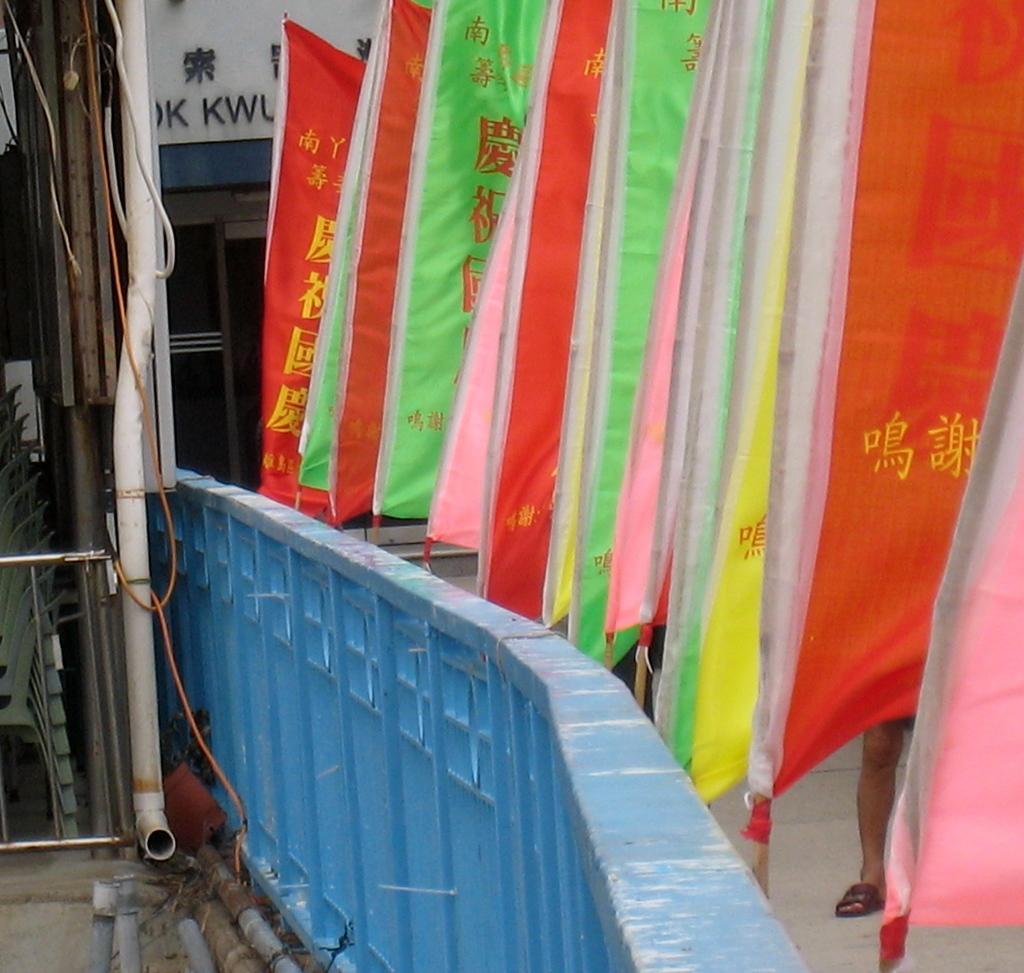Please provide a concise description of this image. On the right side of the image there are flags and there is a person, beside the flags there is a railing. On the left side of the image there are chairs and some other objects. In the background there is a building. 